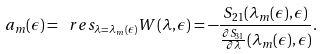<formula> <loc_0><loc_0><loc_500><loc_500>a _ { m } ( \epsilon ) = \ r e s _ { \lambda = \lambda _ { m } ( \epsilon ) } W ( \lambda , \epsilon ) = - \frac { S _ { 2 1 } ( \lambda _ { m } ( \epsilon ) , \epsilon ) } { \frac { \partial S _ { 3 1 } } { \partial \lambda } ( \lambda _ { m } ( \epsilon ) , \epsilon ) } .</formula> 